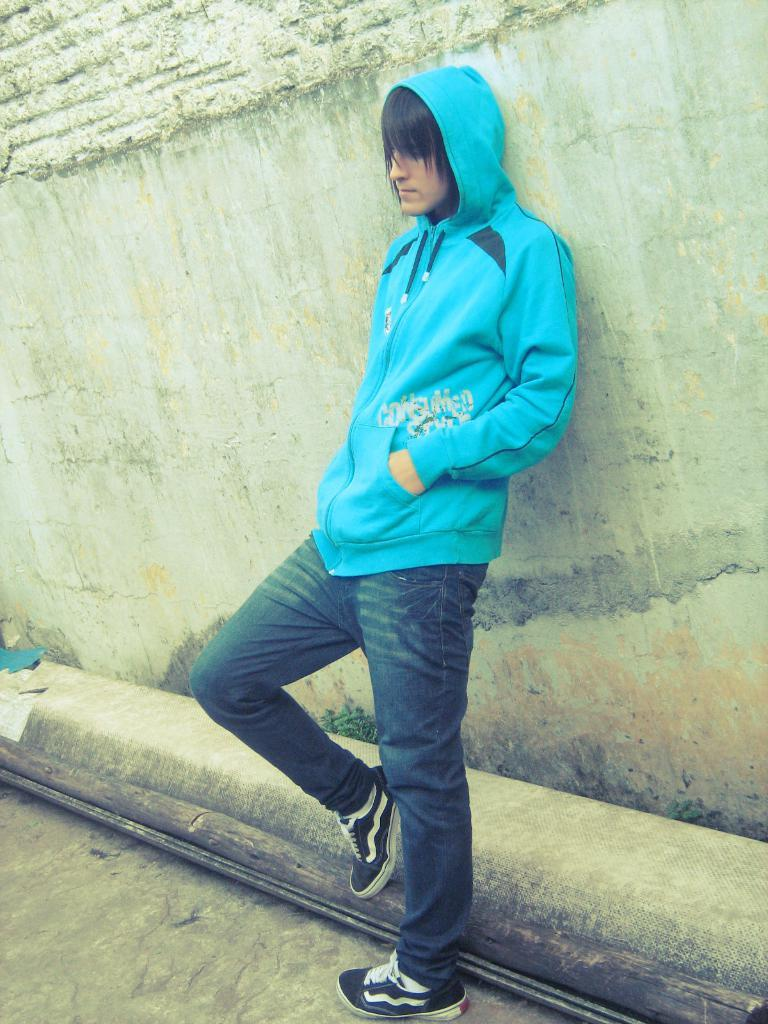Who is present in the image? There is a man in the image. What is the man doing in the image? The man is standing in the image. What is the man wearing on his upper body? The man is wearing a blue hoodie. What type of footwear is the man wearing? The man is wearing black shoes. What can be seen in the background of the image? There is a wall in the background of the image. What news is the man reading from the wall in the image? There is no news present in the image; the man is simply standing near a wall. What does the man believe about the heart in the image? There is no mention of hearts or beliefs in the image; it only features a man standing near a wall. 